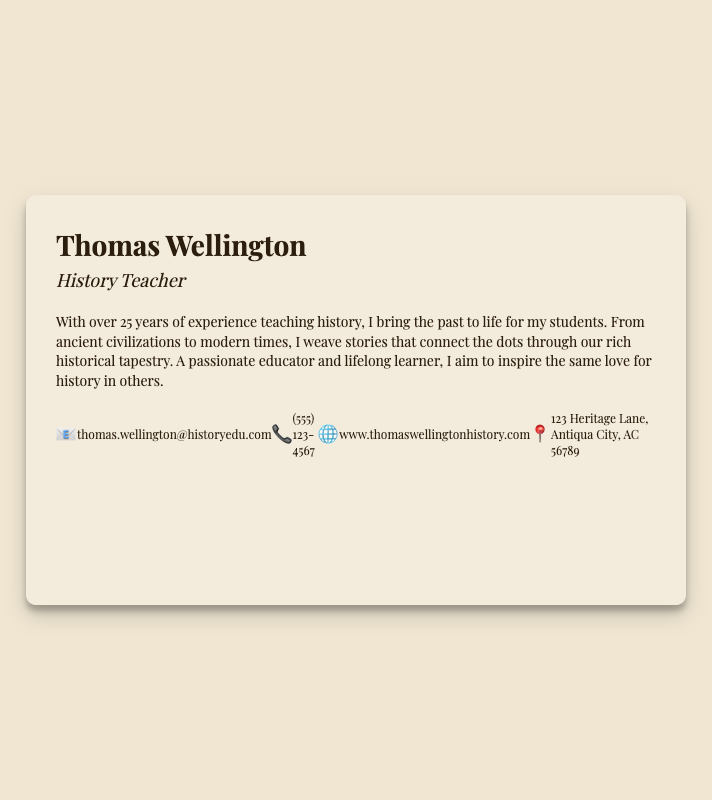What is the name on the business card? The name displayed prominently on the business card is Thomas Wellington.
Answer: Thomas Wellington What is the occupation listed? The occupation stated under the name is History Teacher.
Answer: History Teacher How many years of experience does Thomas Wellington have? The document mentions he has over 25 years of experience.
Answer: 25 years What is the email address provided? The email provided for contact on the business card is thomas.wellington@historyedu.com.
Answer: thomas.wellington@historyedu.com What location is associated with Thomas Wellington? The address mentioned on the card is 123 Heritage Lane, Antiqua City, AC 56789.
Answer: 123 Heritage Lane, Antiqua City, AC 56789 What kind of design is used for the background of the card? The background is described as having an old parchment style.
Answer: Old parchment What does Thomas Wellington aim to inspire in his students? According to the summary, he aims to inspire a love for history in others.
Answer: Love for history What is the website URL listed on the card? The website provided for further information is www.thomaswellingtonhistory.com.
Answer: www.thomaswellingtonhistory.com What type of documents is this? The document is a business card.
Answer: Business card 